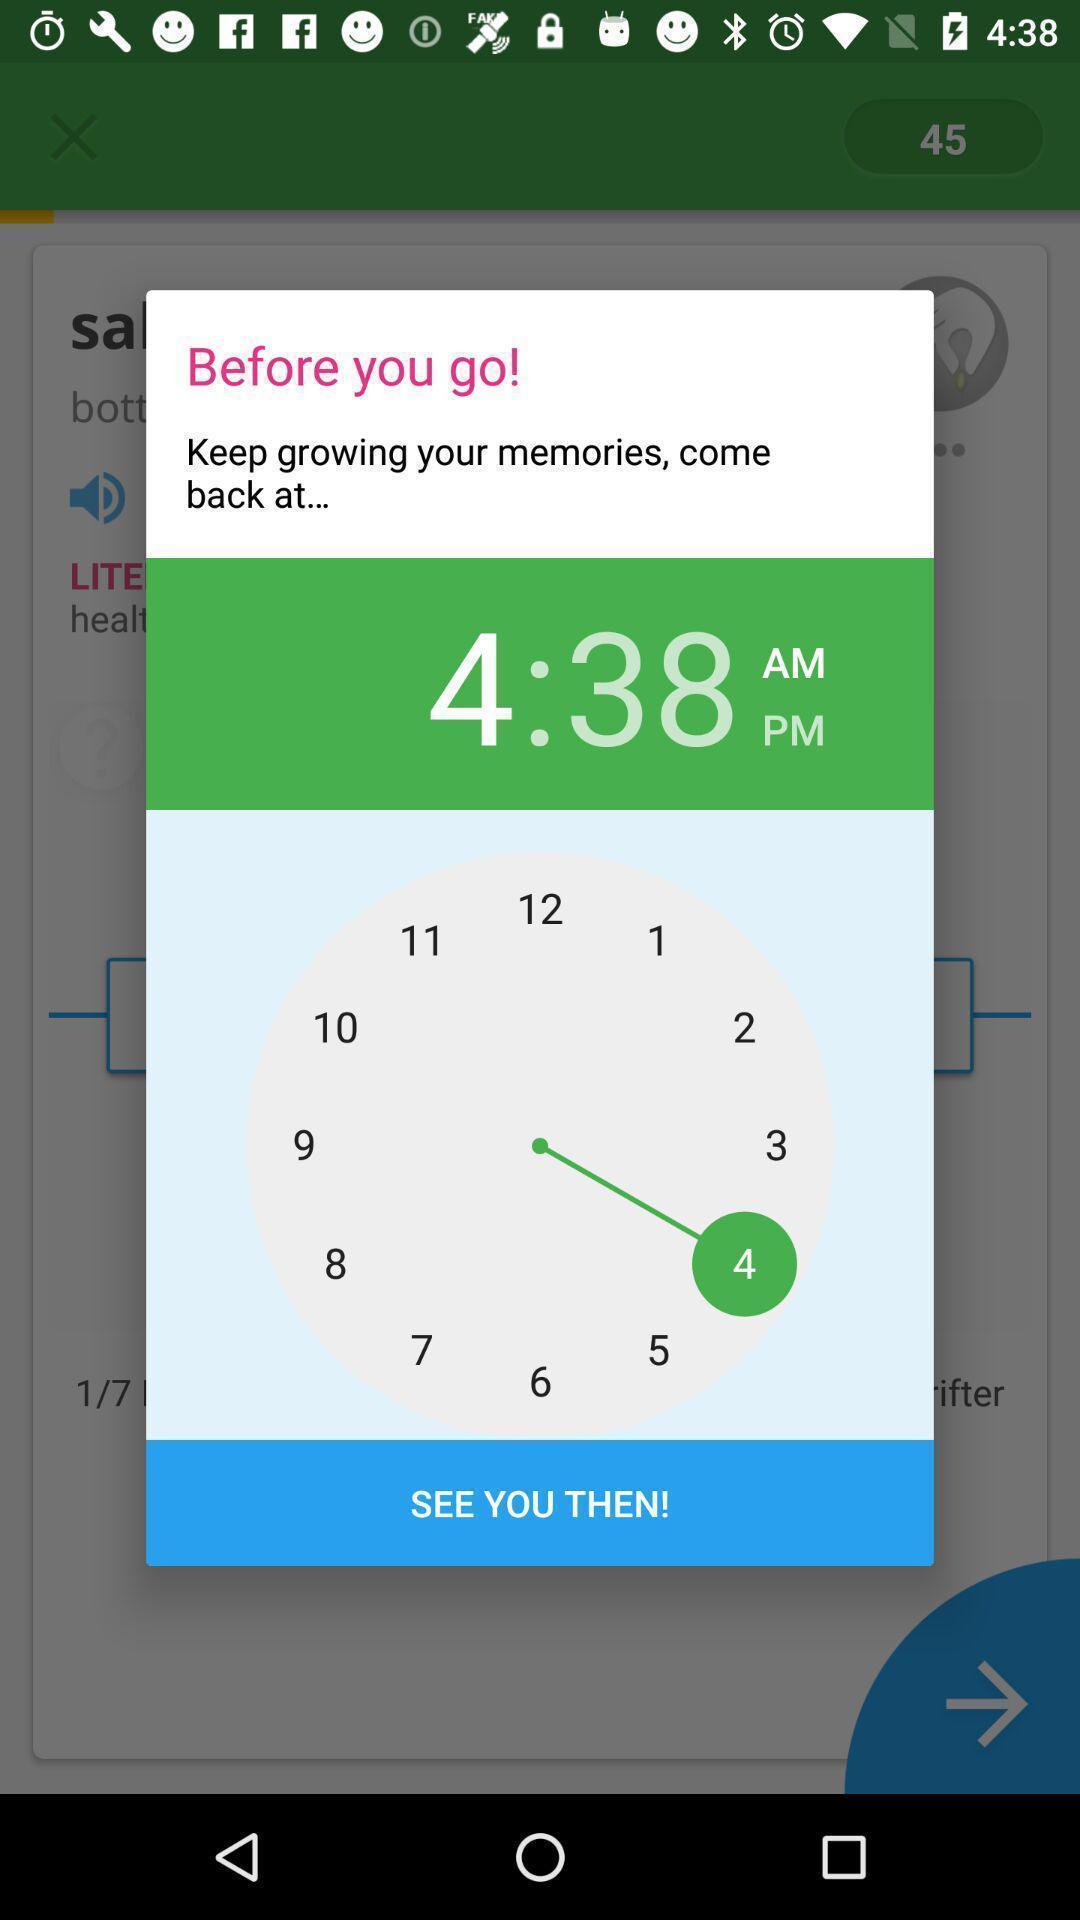Tell me what you see in this picture. Pop-up displaying set a reminder time. 